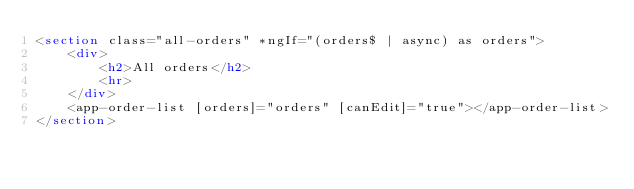<code> <loc_0><loc_0><loc_500><loc_500><_HTML_><section class="all-orders" *ngIf="(orders$ | async) as orders">
	<div>
		<h2>All orders</h2>
		<hr>
	</div>
	<app-order-list [orders]="orders" [canEdit]="true"></app-order-list>
</section></code> 